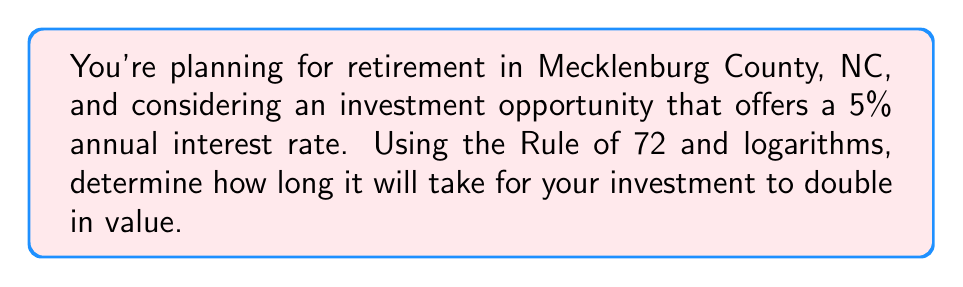Provide a solution to this math problem. Let's approach this problem step-by-step using the Rule of 72 and logarithms:

1) The Rule of 72 states that for an investment to double, the following equation holds:

   $$ 72 = r \times t $$

   where $r$ is the annual interest rate (in percent) and $t$ is the time in years.

2) Given the annual interest rate of 5%, we can set up the equation:

   $$ 72 = 5t $$

3) Solving for $t$:

   $$ t = \frac{72}{5} = 14.4 \text{ years} $$

4) Now, let's verify this result using logarithms. The general formula for compound interest is:

   $$ A = P(1 + r)^t $$

   where $A$ is the final amount, $P$ is the principal (initial investment), $r$ is the interest rate (as a decimal), and $t$ is time in years.

5) For the investment to double, $A = 2P$. Substituting this into the equation:

   $$ 2P = P(1 + 0.05)^t $$

6) Dividing both sides by $P$:

   $$ 2 = (1.05)^t $$

7) Taking the natural logarithm of both sides:

   $$ \ln(2) = t \times \ln(1.05) $$

8) Solving for $t$:

   $$ t = \frac{\ln(2)}{\ln(1.05)} \approx 14.2067 \text{ years} $$

9) This result is very close to the Rule of 72 approximation, confirming its accuracy for practical use.
Answer: 14.4 years 